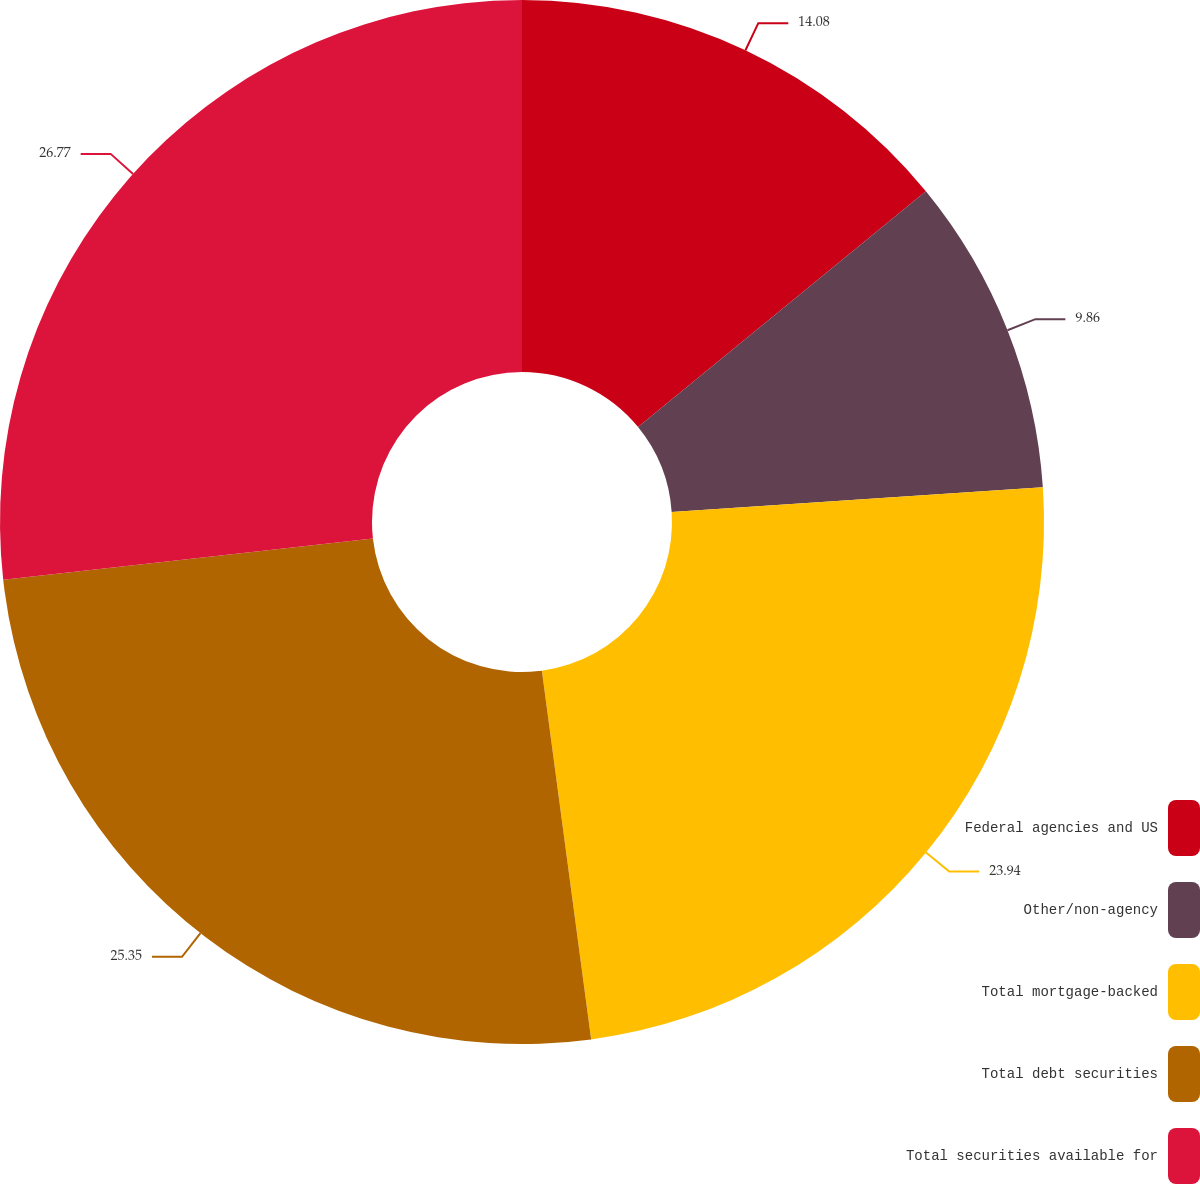Convert chart. <chart><loc_0><loc_0><loc_500><loc_500><pie_chart><fcel>Federal agencies and US<fcel>Other/non-agency<fcel>Total mortgage-backed<fcel>Total debt securities<fcel>Total securities available for<nl><fcel>14.08%<fcel>9.86%<fcel>23.94%<fcel>25.35%<fcel>26.76%<nl></chart> 